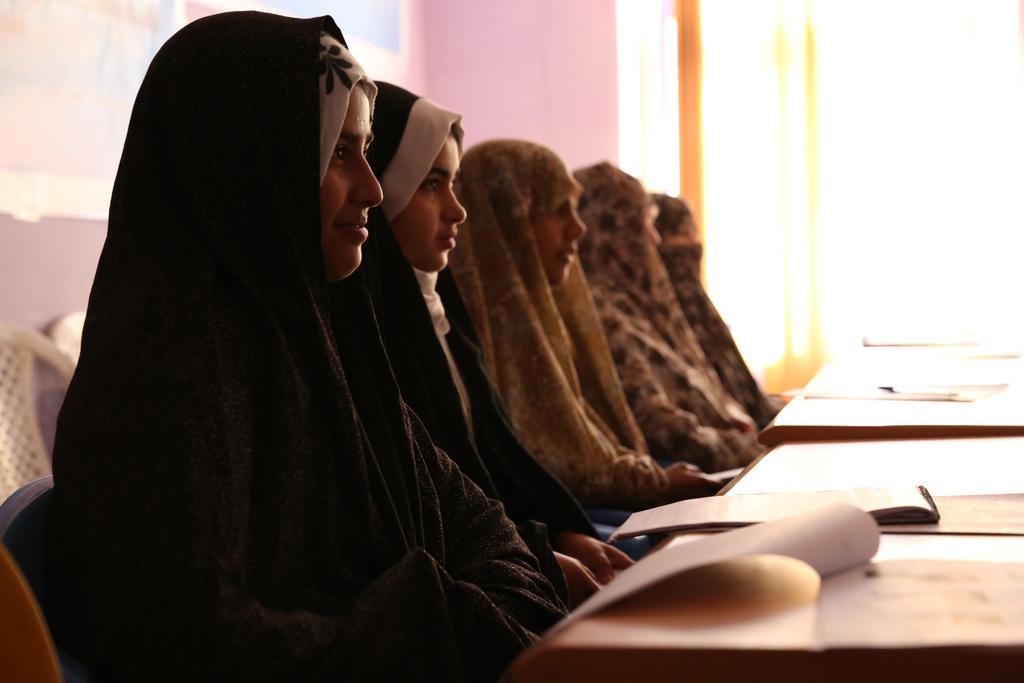In one or two sentences, can you explain what this image depicts? In this picture we can see some persons are sitting on the chairs. This is the table. On the table there is a book. And on the background there is a wall. 